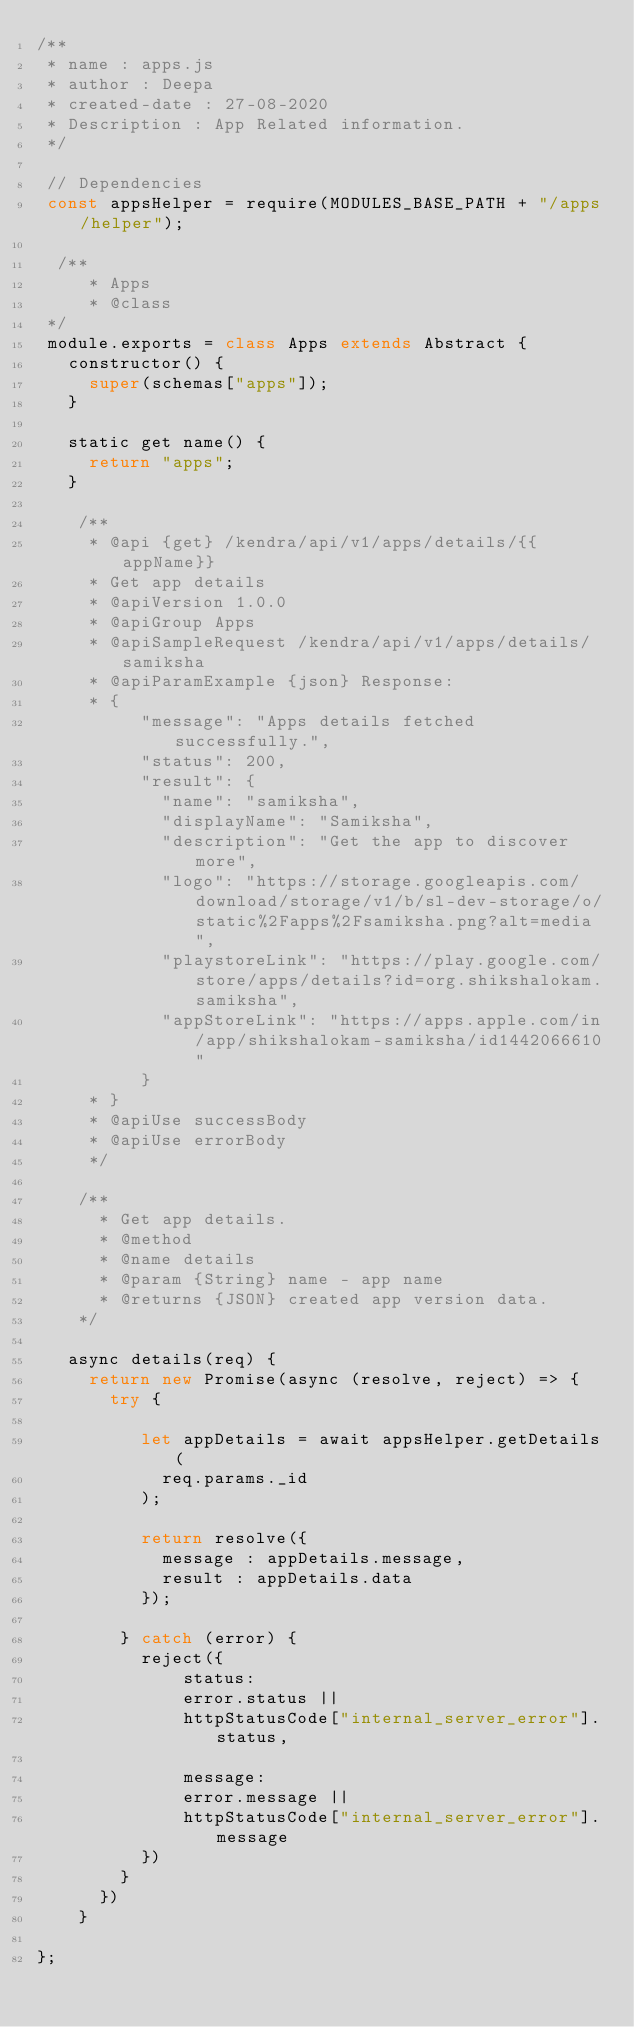<code> <loc_0><loc_0><loc_500><loc_500><_JavaScript_>/**
 * name : apps.js
 * author : Deepa
 * created-date : 27-08-2020
 * Description : App Related information. 
 */

 // Dependencies
 const appsHelper = require(MODULES_BASE_PATH + "/apps/helper");
 
  /**
     * Apps
     * @class
 */
 module.exports = class Apps extends Abstract {
   constructor() {
     super(schemas["apps"]);
   }
 
   static get name() {
     return "apps";
   }

    /**
     * @api {get} /kendra/api/v1/apps/details/{{appName}}
     * Get app details
     * @apiVersion 1.0.0
     * @apiGroup Apps
     * @apiSampleRequest /kendra/api/v1/apps/details/samiksha
     * @apiParamExample {json} Response:
     * {
          "message": "Apps details fetched successfully.",
          "status": 200,
          "result": {
            "name": "samiksha",
            "displayName": "Samiksha",
            "description": "Get the app to discover more",
            "logo": "https://storage.googleapis.com/download/storage/v1/b/sl-dev-storage/o/static%2Fapps%2Fsamiksha.png?alt=media",
            "playstoreLink": "https://play.google.com/store/apps/details?id=org.shikshalokam.samiksha",
            "appStoreLink": "https://apps.apple.com/in/app/shikshalokam-samiksha/id1442066610"
          }
     * }   
     * @apiUse successBody
     * @apiUse errorBody
     */

    /**
      * Get app details.
      * @method
      * @name details
      * @param {String} name - app name
      * @returns {JSON} created app version data.
    */

   async details(req) {
     return new Promise(async (resolve, reject) => {
       try {

          let appDetails = await appsHelper.getDetails(
            req.params._id
          );

          return resolve({
            message : appDetails.message,
            result : appDetails.data
          });
        
        } catch (error) {
          reject({                                        
              status: 
              error.status || 
              httpStatusCode["internal_server_error"].status,

              message: 
              error.message || 
              httpStatusCode["internal_server_error"].message
          })
        }
      })
    }

};
 </code> 